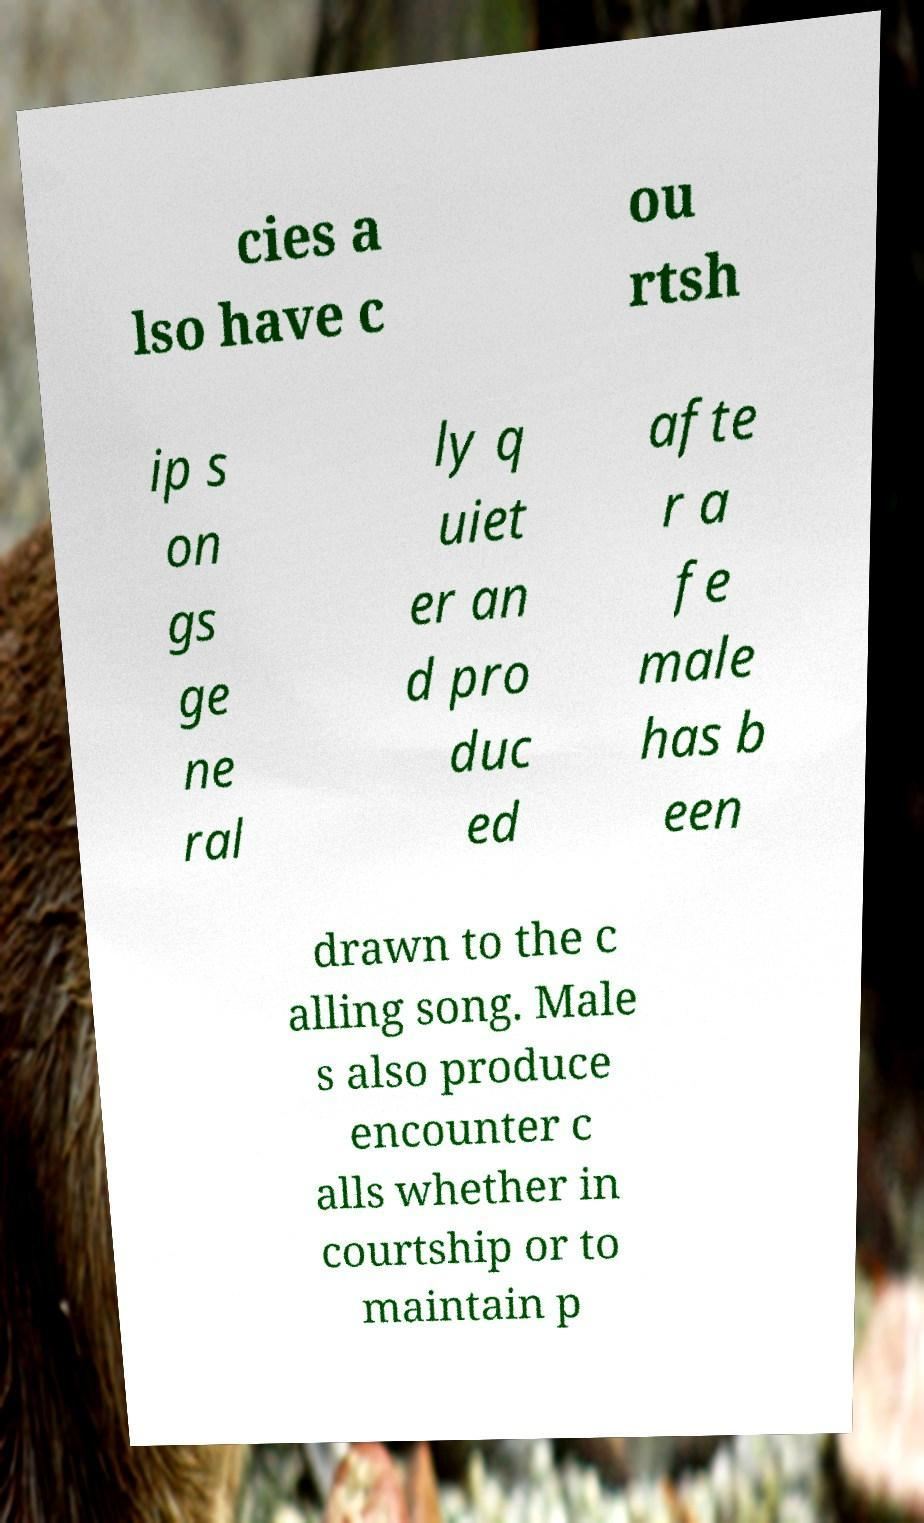Please identify and transcribe the text found in this image. cies a lso have c ou rtsh ip s on gs ge ne ral ly q uiet er an d pro duc ed afte r a fe male has b een drawn to the c alling song. Male s also produce encounter c alls whether in courtship or to maintain p 